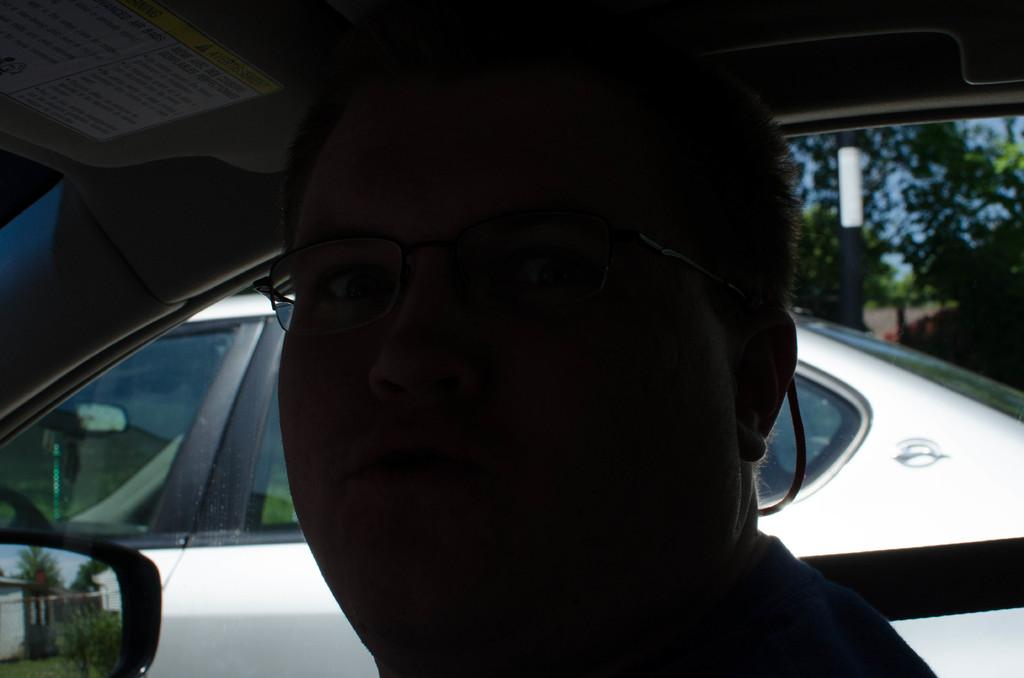What is the man in the image doing? The man is sitting in a car in the image. Can you describe the position of the man's car in relation to other cars? There is another car behind the man's car in the image. What can be seen in the background of the image? There is a tree in the background of the image. What type of breakfast is the man eating in the car? There is no indication in the image that the man is eating breakfast, so it cannot be determined from the picture. 